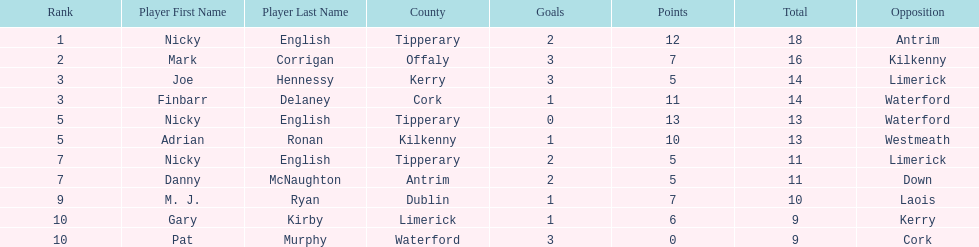Can you parse all the data within this table? {'header': ['Rank', 'Player First Name', 'Player Last Name', 'County', 'Goals', 'Points', 'Total', 'Opposition'], 'rows': [['1', 'Nicky', 'English', 'Tipperary', '2', '12', '18', 'Antrim'], ['2', 'Mark', 'Corrigan', 'Offaly', '3', '7', '16', 'Kilkenny'], ['3', 'Joe', 'Hennessy', 'Kerry', '3', '5', '14', 'Limerick'], ['3', 'Finbarr', 'Delaney', 'Cork', '1', '11', '14', 'Waterford'], ['5', 'Nicky', 'English', 'Tipperary', '0', '13', '13', 'Waterford'], ['5', 'Adrian', 'Ronan', 'Kilkenny', '1', '10', '13', 'Westmeath'], ['7', 'Nicky', 'English', 'Tipperary', '2', '5', '11', 'Limerick'], ['7', 'Danny', 'McNaughton', 'Antrim', '2', '5', '11', 'Down'], ['9', 'M. J.', 'Ryan', 'Dublin', '1', '7', '10', 'Laois'], ['10', 'Gary', 'Kirby', 'Limerick', '1', '6', '9', 'Kerry'], ['10', 'Pat', 'Murphy', 'Waterford', '3', '0', '9', 'Cork']]} What was the average of the totals of nicky english and mark corrigan? 17. 